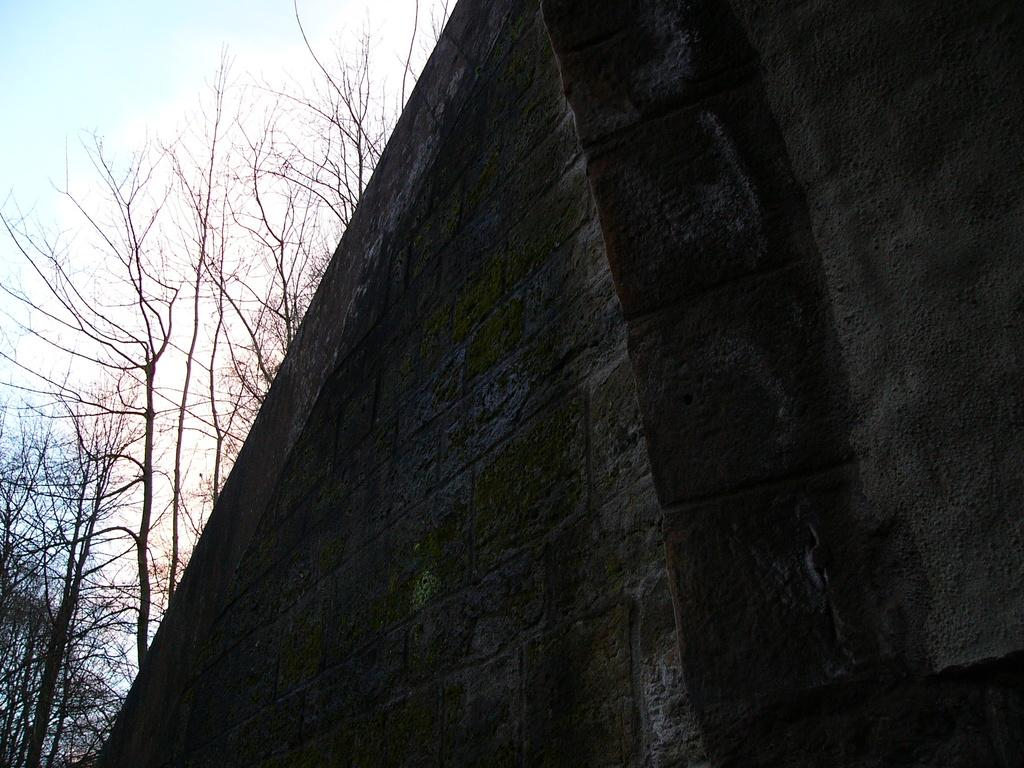What is located in the foreground of the image? There is a wall in the foreground of the image. What can be seen in the background of the image? There are trees and the sky visible in the background of the image. What type of scarf is hanging from the cave in the image? There is no cave or scarf present in the image. 